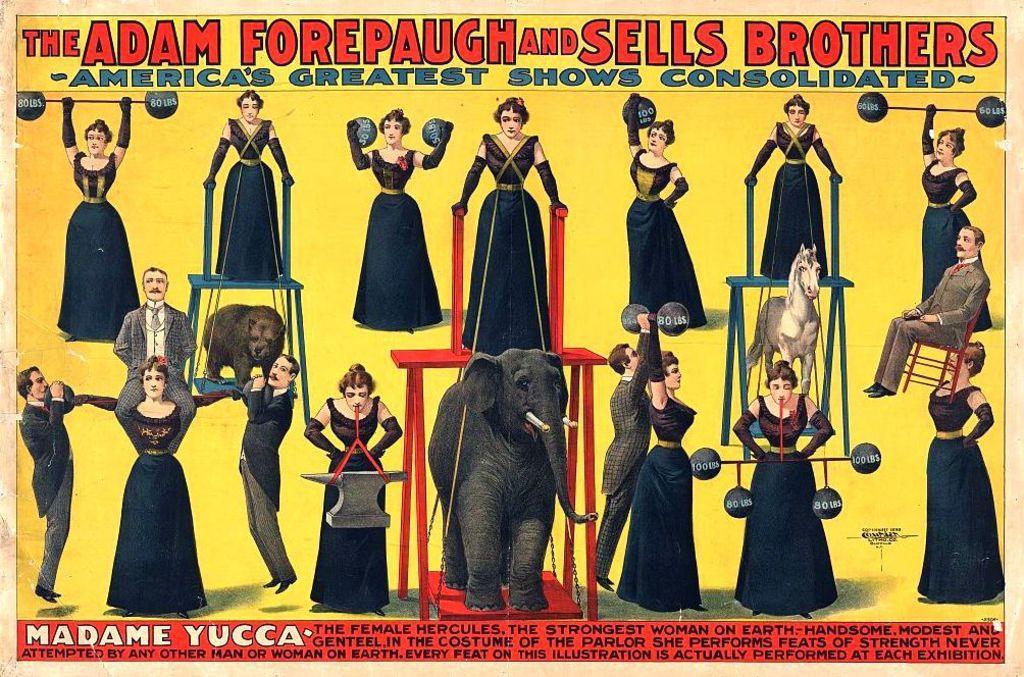Can you describe this image briefly? In this given picture, We can see an image of two animals which include with an elephant after that, We can see a couple of people doing gymnastics, holding few objects and towards the right, We can see a person sitting in chair towards the left, We can see a picture of two people holding two persons including an animal. 